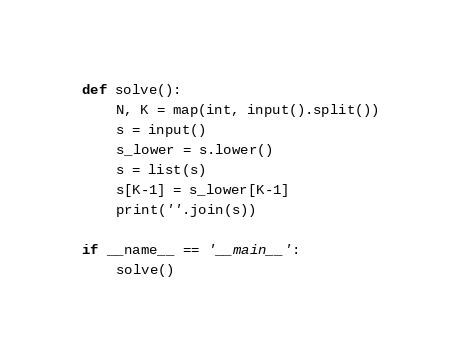<code> <loc_0><loc_0><loc_500><loc_500><_Python_>def solve():
    N, K = map(int, input().split())
    s = input()
    s_lower = s.lower()
    s = list(s)
    s[K-1] = s_lower[K-1]
    print(''.join(s))

if __name__ == '__main__':
    solve()</code> 